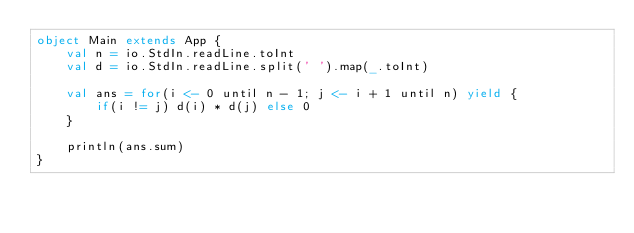Convert code to text. <code><loc_0><loc_0><loc_500><loc_500><_Scala_>object Main extends App {
    val n = io.StdIn.readLine.toInt
    val d = io.StdIn.readLine.split(' ').map(_.toInt)

    val ans = for(i <- 0 until n - 1; j <- i + 1 until n) yield {
        if(i != j) d(i) * d(j) else 0
    }

    println(ans.sum)
}</code> 